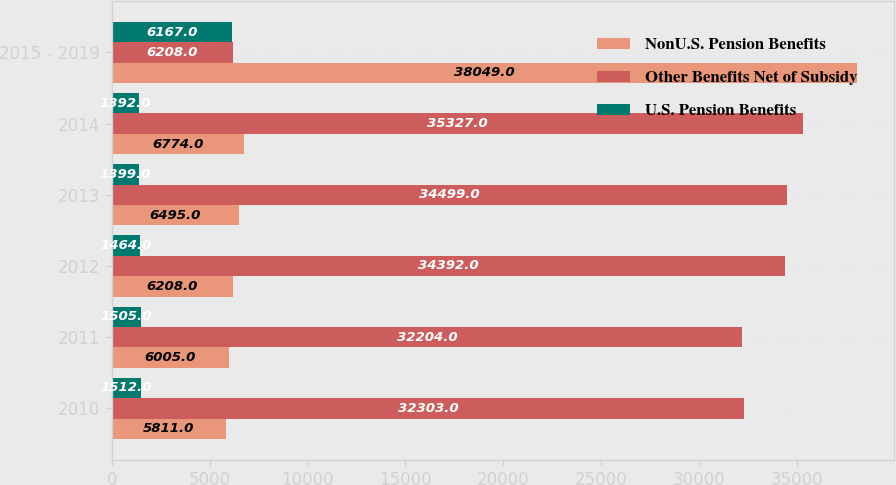Convert chart to OTSL. <chart><loc_0><loc_0><loc_500><loc_500><stacked_bar_chart><ecel><fcel>2010<fcel>2011<fcel>2012<fcel>2013<fcel>2014<fcel>2015 - 2019<nl><fcel>NonU.S. Pension Benefits<fcel>5811<fcel>6005<fcel>6208<fcel>6495<fcel>6774<fcel>38049<nl><fcel>Other Benefits Net of Subsidy<fcel>32303<fcel>32204<fcel>34392<fcel>34499<fcel>35327<fcel>6208<nl><fcel>U.S. Pension Benefits<fcel>1512<fcel>1505<fcel>1464<fcel>1399<fcel>1392<fcel>6167<nl></chart> 